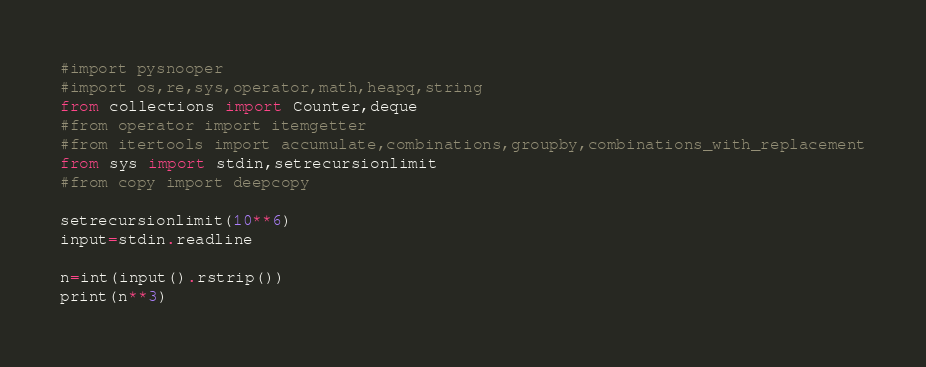<code> <loc_0><loc_0><loc_500><loc_500><_Python_>#import pysnooper
#import os,re,sys,operator,math,heapq,string
from collections import Counter,deque
#from operator import itemgetter
#from itertools import accumulate,combinations,groupby,combinations_with_replacement
from sys import stdin,setrecursionlimit
#from copy import deepcopy

setrecursionlimit(10**6)
input=stdin.readline

n=int(input().rstrip())
print(n**3)</code> 